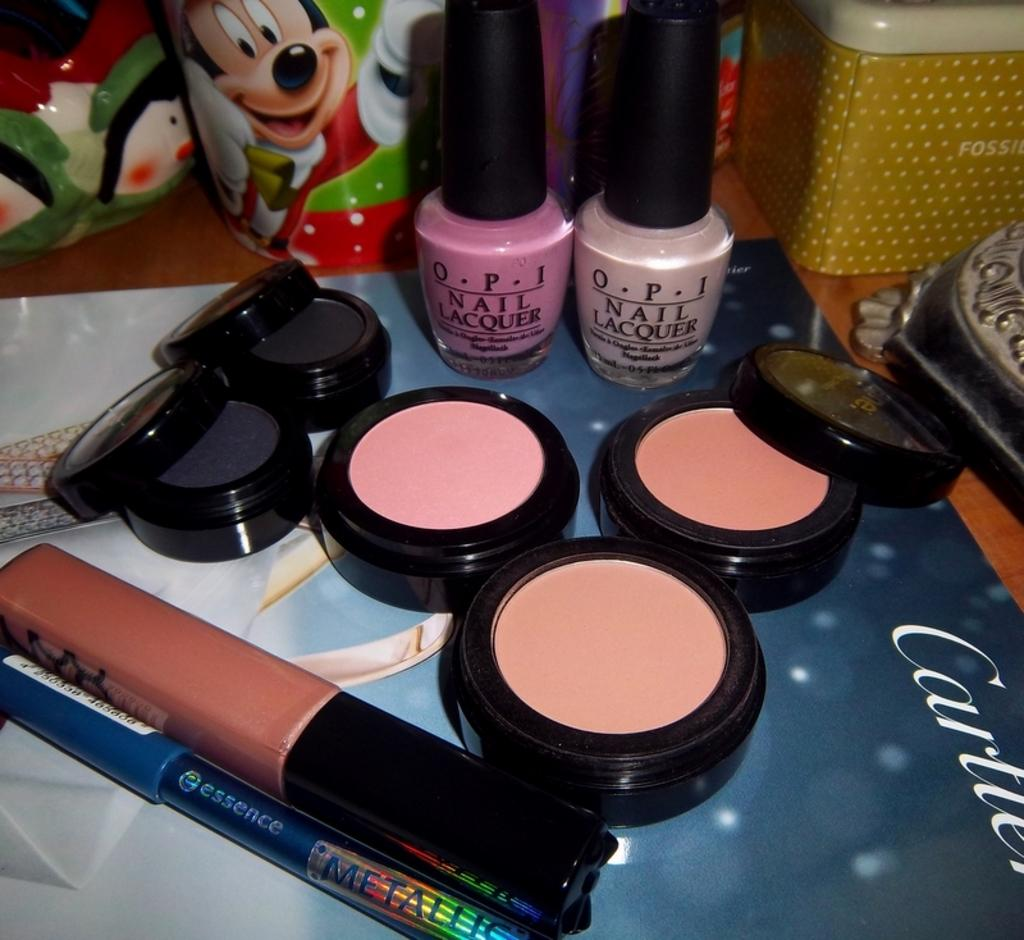What is the main subject of the image? The main subject of the image is a makeup kit. What other items are visible in the image? There are nail polishes in the image. Where are the makeup kit and nail polishes placed? The makeup kit and nail polishes are on a magazine. What else can be seen on the surface in the image? There are objects and containers placed on a surface in the image. What type of key is used to open the makeup kit in the image? There is no key present in the image, as the makeup kit is not shown to be locked. 